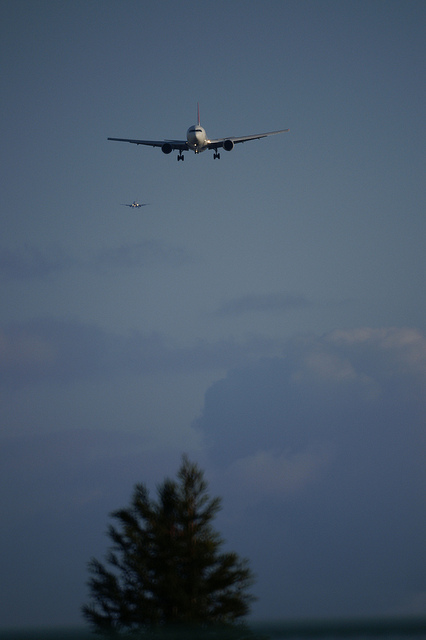<image>What year was this picture taken? I don't know what year this picture was taken, it's not possible to determine from the picture itself. What year was this picture taken? It is unanswerable what year the picture was taken. 